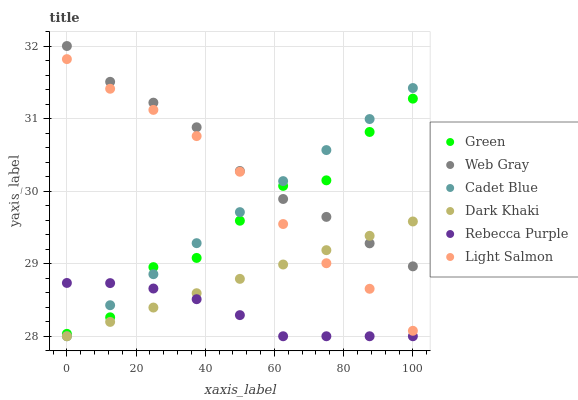Does Rebecca Purple have the minimum area under the curve?
Answer yes or no. Yes. Does Web Gray have the maximum area under the curve?
Answer yes or no. Yes. Does Cadet Blue have the minimum area under the curve?
Answer yes or no. No. Does Cadet Blue have the maximum area under the curve?
Answer yes or no. No. Is Cadet Blue the smoothest?
Answer yes or no. Yes. Is Green the roughest?
Answer yes or no. Yes. Is Dark Khaki the smoothest?
Answer yes or no. No. Is Dark Khaki the roughest?
Answer yes or no. No. Does Cadet Blue have the lowest value?
Answer yes or no. Yes. Does Web Gray have the lowest value?
Answer yes or no. No. Does Web Gray have the highest value?
Answer yes or no. Yes. Does Cadet Blue have the highest value?
Answer yes or no. No. Is Rebecca Purple less than Web Gray?
Answer yes or no. Yes. Is Light Salmon greater than Rebecca Purple?
Answer yes or no. Yes. Does Light Salmon intersect Green?
Answer yes or no. Yes. Is Light Salmon less than Green?
Answer yes or no. No. Is Light Salmon greater than Green?
Answer yes or no. No. Does Rebecca Purple intersect Web Gray?
Answer yes or no. No. 